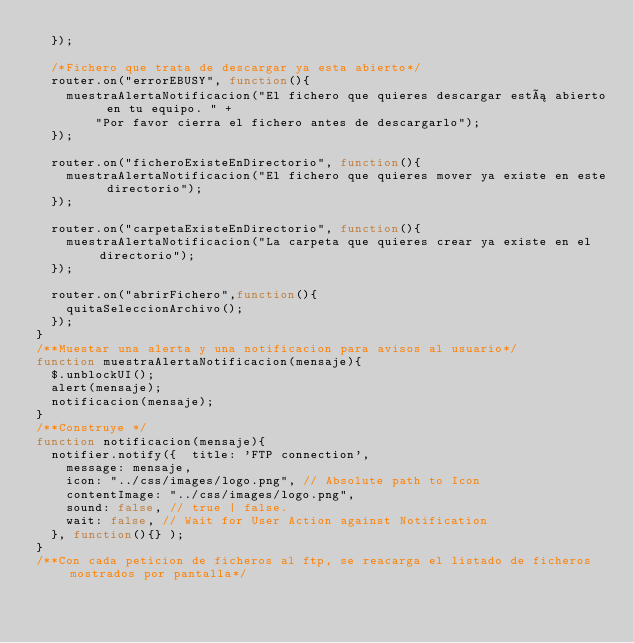Convert code to text. <code><loc_0><loc_0><loc_500><loc_500><_JavaScript_>	});

	/*Fichero que trata de descargar ya esta abierto*/
	router.on("errorEBUSY", function(){
		muestraAlertaNotificacion("El fichero que quieres descargar está abierto en tu equipo. " +
				"Por favor cierra el fichero antes de descargarlo");
	});
	
	router.on("ficheroExisteEnDirectorio", function(){
		muestraAlertaNotificacion("El fichero que quieres mover ya existe en este directorio");
	});	
	
	router.on("carpetaExisteEnDirectorio", function(){
		muestraAlertaNotificacion("La carpeta que quieres crear ya existe en el directorio");
	});	
	
	router.on("abrirFichero",function(){
		quitaSeleccionArchivo();
	});
}
/**Muestar una alerta y una notificacion para avisos al usuario*/
function muestraAlertaNotificacion(mensaje){
	$.unblockUI();
	alert(mensaje);
	notificacion(mensaje);
}
/**Construye */
function notificacion(mensaje){
	notifier.notify({  title: 'FTP connection',
		message: mensaje,
		icon: "../css/images/logo.png", // Absolute path to Icon
		contentImage: "../css/images/logo.png",
		sound: false, // true | false.
		wait: false, // Wait for User Action against Notification
	}, function(){} );
}
/**Con cada peticion de ficheros al ftp, se reacarga el listado de ficheros mostrados por pantalla*/</code> 